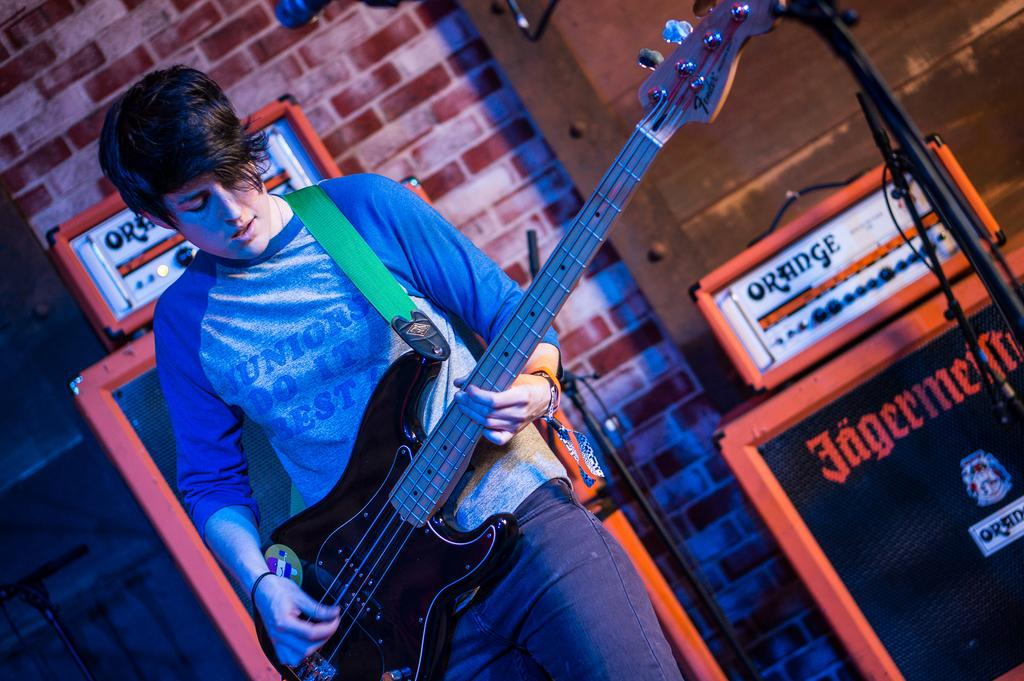What is the main subject of the image? There is a person in the image. What is the person holding in the image? The person is holding a guitar. What other objects can be seen in the image? There are speakers visible in the image. What type of snail can be seen crawling on the guitar in the image? There is no snail present in the image; the person is holding a guitar without any visible snails. 